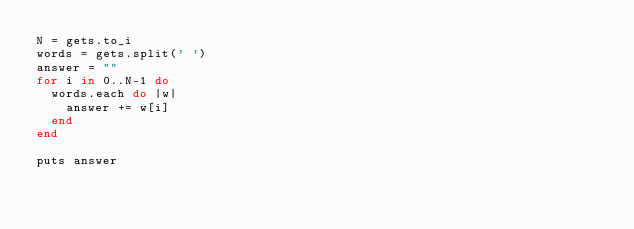<code> <loc_0><loc_0><loc_500><loc_500><_Ruby_>N = gets.to_i
words = gets.split(' ')
answer = ""
for i in 0..N-1 do
  words.each do |w|
    answer += w[i]
  end
end

puts answer</code> 